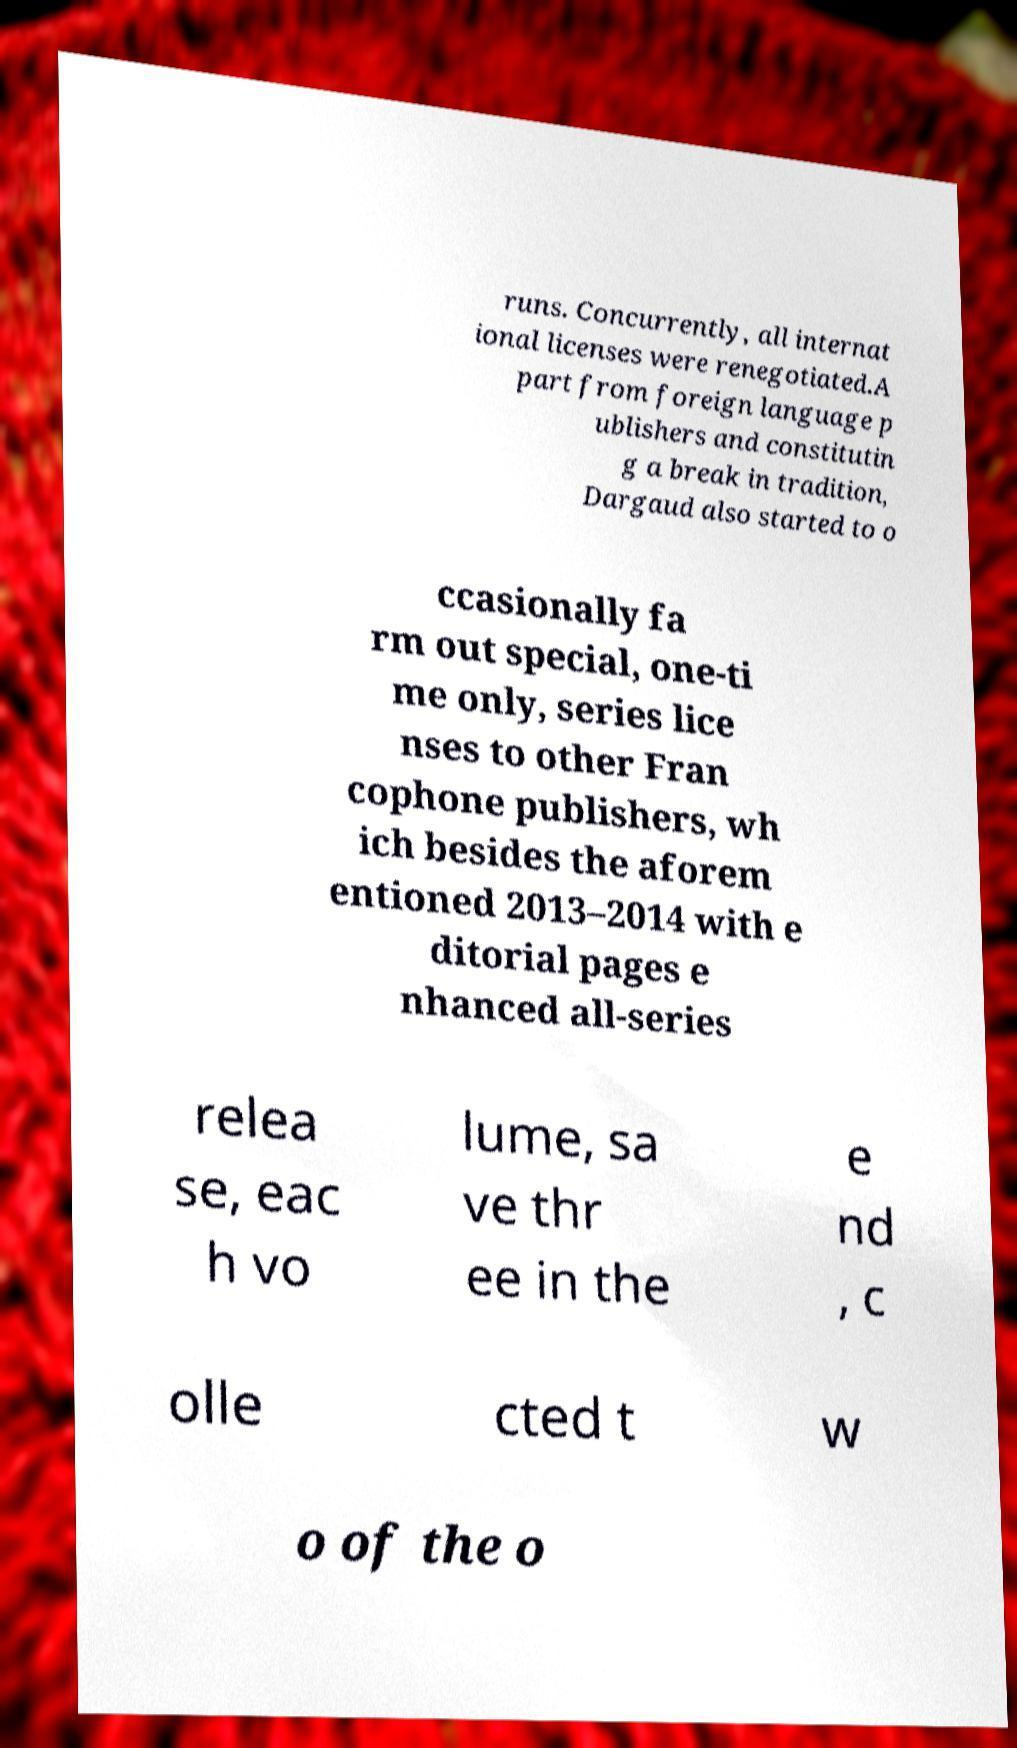Could you extract and type out the text from this image? runs. Concurrently, all internat ional licenses were renegotiated.A part from foreign language p ublishers and constitutin g a break in tradition, Dargaud also started to o ccasionally fa rm out special, one-ti me only, series lice nses to other Fran cophone publishers, wh ich besides the aforem entioned 2013–2014 with e ditorial pages e nhanced all-series relea se, eac h vo lume, sa ve thr ee in the e nd , c olle cted t w o of the o 